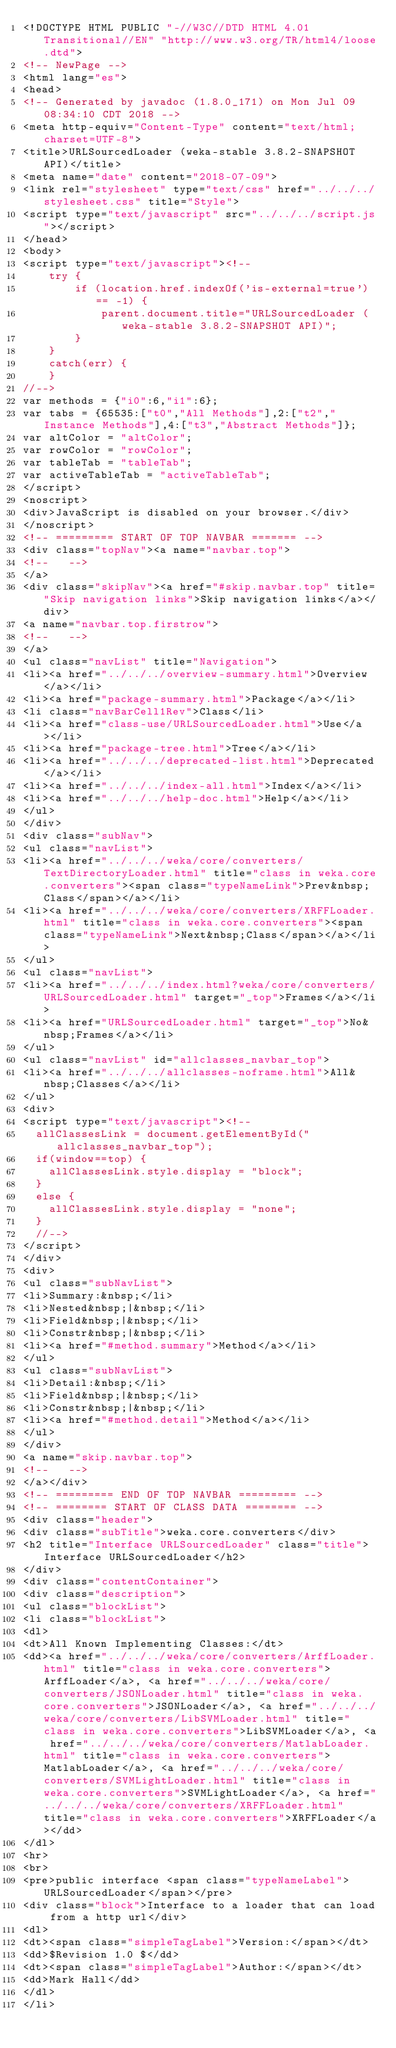Convert code to text. <code><loc_0><loc_0><loc_500><loc_500><_HTML_><!DOCTYPE HTML PUBLIC "-//W3C//DTD HTML 4.01 Transitional//EN" "http://www.w3.org/TR/html4/loose.dtd">
<!-- NewPage -->
<html lang="es">
<head>
<!-- Generated by javadoc (1.8.0_171) on Mon Jul 09 08:34:10 CDT 2018 -->
<meta http-equiv="Content-Type" content="text/html; charset=UTF-8">
<title>URLSourcedLoader (weka-stable 3.8.2-SNAPSHOT API)</title>
<meta name="date" content="2018-07-09">
<link rel="stylesheet" type="text/css" href="../../../stylesheet.css" title="Style">
<script type="text/javascript" src="../../../script.js"></script>
</head>
<body>
<script type="text/javascript"><!--
    try {
        if (location.href.indexOf('is-external=true') == -1) {
            parent.document.title="URLSourcedLoader (weka-stable 3.8.2-SNAPSHOT API)";
        }
    }
    catch(err) {
    }
//-->
var methods = {"i0":6,"i1":6};
var tabs = {65535:["t0","All Methods"],2:["t2","Instance Methods"],4:["t3","Abstract Methods"]};
var altColor = "altColor";
var rowColor = "rowColor";
var tableTab = "tableTab";
var activeTableTab = "activeTableTab";
</script>
<noscript>
<div>JavaScript is disabled on your browser.</div>
</noscript>
<!-- ========= START OF TOP NAVBAR ======= -->
<div class="topNav"><a name="navbar.top">
<!--   -->
</a>
<div class="skipNav"><a href="#skip.navbar.top" title="Skip navigation links">Skip navigation links</a></div>
<a name="navbar.top.firstrow">
<!--   -->
</a>
<ul class="navList" title="Navigation">
<li><a href="../../../overview-summary.html">Overview</a></li>
<li><a href="package-summary.html">Package</a></li>
<li class="navBarCell1Rev">Class</li>
<li><a href="class-use/URLSourcedLoader.html">Use</a></li>
<li><a href="package-tree.html">Tree</a></li>
<li><a href="../../../deprecated-list.html">Deprecated</a></li>
<li><a href="../../../index-all.html">Index</a></li>
<li><a href="../../../help-doc.html">Help</a></li>
</ul>
</div>
<div class="subNav">
<ul class="navList">
<li><a href="../../../weka/core/converters/TextDirectoryLoader.html" title="class in weka.core.converters"><span class="typeNameLink">Prev&nbsp;Class</span></a></li>
<li><a href="../../../weka/core/converters/XRFFLoader.html" title="class in weka.core.converters"><span class="typeNameLink">Next&nbsp;Class</span></a></li>
</ul>
<ul class="navList">
<li><a href="../../../index.html?weka/core/converters/URLSourcedLoader.html" target="_top">Frames</a></li>
<li><a href="URLSourcedLoader.html" target="_top">No&nbsp;Frames</a></li>
</ul>
<ul class="navList" id="allclasses_navbar_top">
<li><a href="../../../allclasses-noframe.html">All&nbsp;Classes</a></li>
</ul>
<div>
<script type="text/javascript"><!--
  allClassesLink = document.getElementById("allclasses_navbar_top");
  if(window==top) {
    allClassesLink.style.display = "block";
  }
  else {
    allClassesLink.style.display = "none";
  }
  //-->
</script>
</div>
<div>
<ul class="subNavList">
<li>Summary:&nbsp;</li>
<li>Nested&nbsp;|&nbsp;</li>
<li>Field&nbsp;|&nbsp;</li>
<li>Constr&nbsp;|&nbsp;</li>
<li><a href="#method.summary">Method</a></li>
</ul>
<ul class="subNavList">
<li>Detail:&nbsp;</li>
<li>Field&nbsp;|&nbsp;</li>
<li>Constr&nbsp;|&nbsp;</li>
<li><a href="#method.detail">Method</a></li>
</ul>
</div>
<a name="skip.navbar.top">
<!--   -->
</a></div>
<!-- ========= END OF TOP NAVBAR ========= -->
<!-- ======== START OF CLASS DATA ======== -->
<div class="header">
<div class="subTitle">weka.core.converters</div>
<h2 title="Interface URLSourcedLoader" class="title">Interface URLSourcedLoader</h2>
</div>
<div class="contentContainer">
<div class="description">
<ul class="blockList">
<li class="blockList">
<dl>
<dt>All Known Implementing Classes:</dt>
<dd><a href="../../../weka/core/converters/ArffLoader.html" title="class in weka.core.converters">ArffLoader</a>, <a href="../../../weka/core/converters/JSONLoader.html" title="class in weka.core.converters">JSONLoader</a>, <a href="../../../weka/core/converters/LibSVMLoader.html" title="class in weka.core.converters">LibSVMLoader</a>, <a href="../../../weka/core/converters/MatlabLoader.html" title="class in weka.core.converters">MatlabLoader</a>, <a href="../../../weka/core/converters/SVMLightLoader.html" title="class in weka.core.converters">SVMLightLoader</a>, <a href="../../../weka/core/converters/XRFFLoader.html" title="class in weka.core.converters">XRFFLoader</a></dd>
</dl>
<hr>
<br>
<pre>public interface <span class="typeNameLabel">URLSourcedLoader</span></pre>
<div class="block">Interface to a loader that can load from a http url</div>
<dl>
<dt><span class="simpleTagLabel">Version:</span></dt>
<dd>$Revision 1.0 $</dd>
<dt><span class="simpleTagLabel">Author:</span></dt>
<dd>Mark Hall</dd>
</dl>
</li></code> 